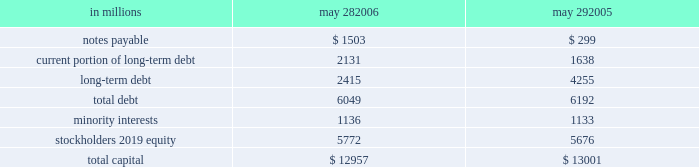During fiscal 2006 , we repurchased 19 million shares of common stock for an aggregate purchase price of $ 892 million , of which $ 7 million settled after the end of our fiscal year .
In fiscal 2005 , we repurchased 17 million shares of common stock for an aggregate purchase price of $ 771 million .
A total of 146 million shares were held in treasury at may 28 , 2006 .
We also used cash from operations to repay $ 189 million in outstanding debt in fiscal 2006 .
In fiscal 2005 , we repaid nearly $ 2.2 billion of debt , including the purchase of $ 760 million principal amount of our 6 percent notes due in 2012 .
Fiscal 2005 debt repurchase costs were $ 137 million , consisting of $ 73 million of noncash interest rate swap losses reclassified from accumulated other comprehen- sive income , $ 59 million of purchase premium and $ 5 million of noncash unamortized cost of issuance expense .
Capital structure in millions may 28 , may 29 .
We have $ 2.1 billion of long-term debt maturing in the next 12 months and classified as current , including $ 131 million that may mature in fiscal 2007 based on the put rights of those note holders .
We believe that cash flows from operations , together with available short- and long- term debt financing , will be adequate to meet our liquidity and capital needs for at least the next 12 months .
On october 28 , 2005 , we repurchased a significant portion of our zero coupon convertible debentures pursuant to put rights of the holders for an aggregate purchase price of $ 1.33 billion , including $ 77 million of accreted original issue discount .
These debentures had an aggregate prin- cipal amount at maturity of $ 1.86 billion .
We incurred no gain or loss from this repurchase .
As of may 28 , 2006 , there were $ 371 million in aggregate principal amount at matu- rity of the debentures outstanding , or $ 268 million of accreted value .
We used proceeds from the issuance of commercial paper to fund the purchase price of the deben- tures .
We also have reclassified the remaining zero coupon convertible debentures to long-term debt based on the october 2008 put rights of the holders .
On march 23 , 2005 , we commenced a cash tender offer for our outstanding 6 percent notes due in 2012 .
The tender offer resulted in the purchase of $ 500 million principal amount of the notes .
Subsequent to the expiration of the tender offer , we purchased an additional $ 260 million prin- cipal amount of the notes in the open market .
The aggregate purchases resulted in the debt repurchase costs as discussed above .
Our minority interests consist of interests in certain of our subsidiaries that are held by third parties .
General mills cereals , llc ( gmc ) , our subsidiary , holds the manufac- turing assets and intellectual property associated with the production and retail sale of big g ready-to-eat cereals , progresso soups and old el paso products .
In may 2002 , one of our wholly owned subsidiaries sold 150000 class a preferred membership interests in gmc to an unrelated third-party investor in exchange for $ 150 million , and in october 2004 , another of our wholly owned subsidiaries sold 835000 series b-1 preferred membership interests in gmc in exchange for $ 835 million .
All interests in gmc , other than the 150000 class a interests and 835000 series b-1 interests , but including all managing member inter- ests , are held by our wholly owned subsidiaries .
In fiscal 2003 , general mills capital , inc .
( gm capital ) , a subsidiary formed for the purpose of purchasing and collecting our receivables , sold $ 150 million of its series a preferred stock to an unrelated third-party investor .
The class a interests of gmc receive quarterly preferred distributions at a floating rate equal to ( i ) the sum of three- month libor plus 90 basis points , divided by ( ii ) 0.965 .
This rate will be adjusted by agreement between the third- party investor holding the class a interests and gmc every five years , beginning in june 2007 .
Under certain circum- stances , gmc also may be required to be dissolved and liquidated , including , without limitation , the bankruptcy of gmc or its subsidiaries , failure to deliver the preferred distributions , failure to comply with portfolio requirements , breaches of certain covenants , lowering of our senior debt rating below either baa3 by moody 2019s or bbb by standard & poor 2019s , and a failed attempt to remarket the class a inter- ests as a result of a breach of gmc 2019s obligations to assist in such remarketing .
In the event of a liquidation of gmc , each member of gmc would receive the amount of its then current capital account balance .
The managing member may avoid liquidation in most circumstances by exercising an option to purchase the class a interests .
The series b-1 interests of gmc are entitled to receive quarterly preferred distributions at a fixed rate of 4.5 percent per year , which is scheduled to be reset to a new fixed rate through a remarketing in october 2007 .
Beginning in october 2007 , the managing member of gmc may elect to repurchase the series b-1 interests for an amount equal to the holder 2019s then current capital account balance plus any applicable make-whole amount .
Gmc is not required to purchase the series b-1 interests nor may these investors put these interests to us .
The series b-1 interests will be exchanged for shares of our perpetual preferred stock upon the occurrence of any of the following events : our senior unsecured debt rating falling below either ba3 as rated by moody 2019s or bb- as rated by standard & poor 2019s or fitch , inc. .
In 2006 what was the percent of the capital structure of total debt that was current portion of long-term debt? 
Computations: (2131 / 6049)
Answer: 0.35229. 